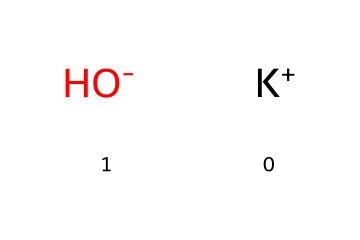What is the name of this chemical? The given chemical structure corresponds to potassium hydroxide, which consists of potassium (K) and hydroxide (OH) ions.
Answer: potassium hydroxide How many distinct elements are present in this compound? Analyzing the chemical structure, there are two distinct elements: potassium (K) and oxygen (from hydroxide) along with hydrogen.
Answer: two What is the charge of the potassium ion in this structure? The potassium ion (K+) carries a positive charge, as indicated by the '+' symbol next to K in the structure.
Answer: positive What type of chemical bond connects the potassium ion and hydroxide ion? The bond between the potassium ion and hydroxide ion is an ionic bond, characterized by the electrostatic attraction between the positively charged potassium and the negatively charged hydroxide.
Answer: ionic bond Is potassium hydroxide considered a strong or weak base? Potassium hydroxide is classified as a strong base due to its high degree of dissociation in water, producing significant amounts of hydroxide ions.
Answer: strong base How many total atoms are present in this compound's formula? In potassium hydroxide, we find one potassium atom (K), one oxygen atom (O), and one hydrogen atom (H), totaling three atoms.
Answer: three What role does potassium hydroxide play in soap-making? Potassium hydroxide acts as a saponification agent, reacting with fats or oils to produce soap and glycerol.
Answer: saponification agent 